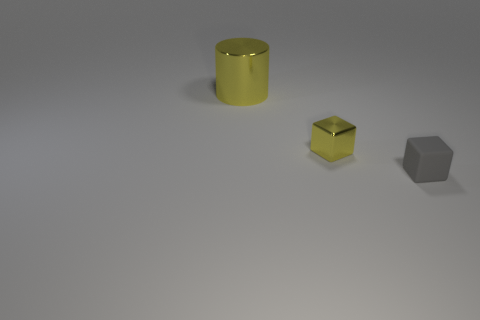Add 2 big yellow shiny objects. How many objects exist? 5 Add 2 brown metallic balls. How many brown metallic balls exist? 2 Subtract all yellow cubes. How many cubes are left? 1 Subtract 0 red blocks. How many objects are left? 3 Subtract all blocks. How many objects are left? 1 Subtract all purple cylinders. Subtract all red balls. How many cylinders are left? 1 Subtract all gray cylinders. How many blue blocks are left? 0 Subtract all big red metal cylinders. Subtract all small yellow metallic cubes. How many objects are left? 2 Add 1 small gray blocks. How many small gray blocks are left? 2 